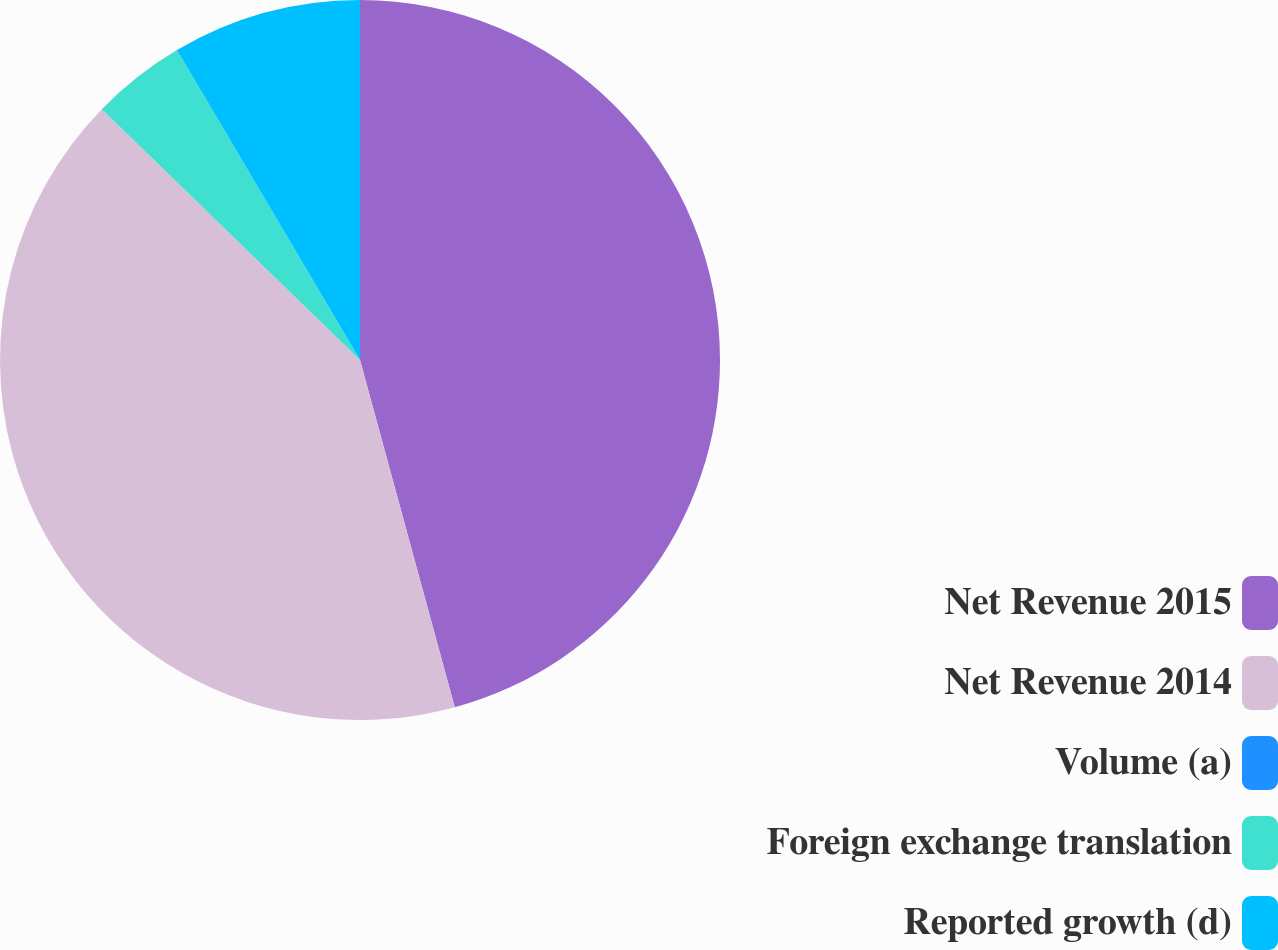Convert chart. <chart><loc_0><loc_0><loc_500><loc_500><pie_chart><fcel>Net Revenue 2015<fcel>Net Revenue 2014<fcel>Volume (a)<fcel>Foreign exchange translation<fcel>Reported growth (d)<nl><fcel>45.76%<fcel>41.51%<fcel>0.0%<fcel>4.24%<fcel>8.49%<nl></chart> 